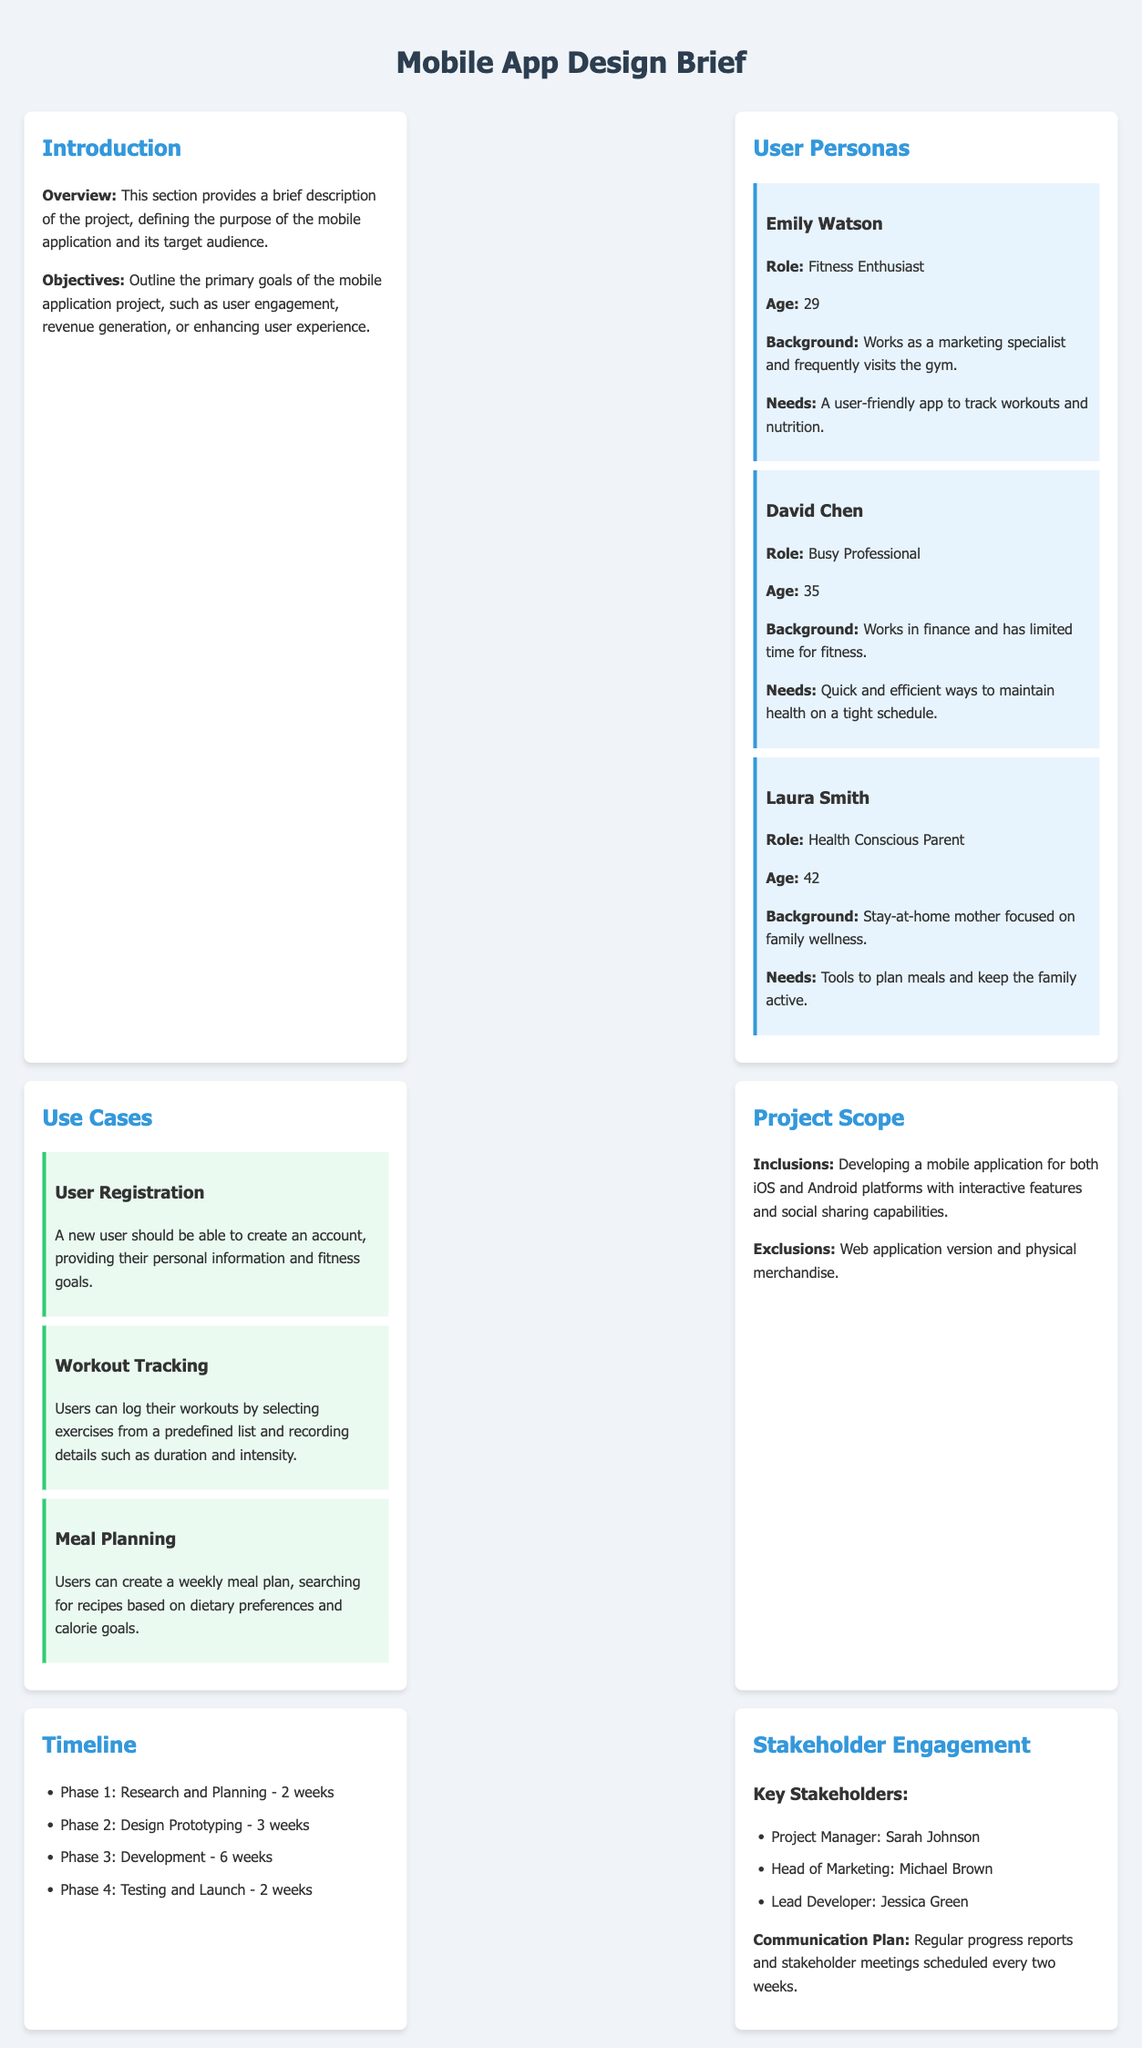What is the age of Emily Watson? Emily Watson's age is listed under her persona section.
Answer: 29 What is the role of David Chen? David Chen's role is specified in the user persona section.
Answer: Busy Professional What is the duration of the research and planning phase? The timeline outlines the duration for each project phase.
Answer: 2 weeks What is one of the objectives of the mobile application project? The objectives section states the primary goals of the project.
Answer: User engagement Who is the Lead Developer? The key stakeholders section lists the roles and names.
Answer: Jessica Green What feature is excluded from the project scope? The project scope outlines inclusions and exclusions regarding features.
Answer: Web application version How many user personas are presented in the document? The user personas section counts the number of distinct personas.
Answer: 3 What is the estimated time for the testing and launch phase? The timeline provides estimated durations for each project phase.
Answer: 2 weeks What type of application is being developed? The project scope identifies the type of application to be developed.
Answer: Mobile application 